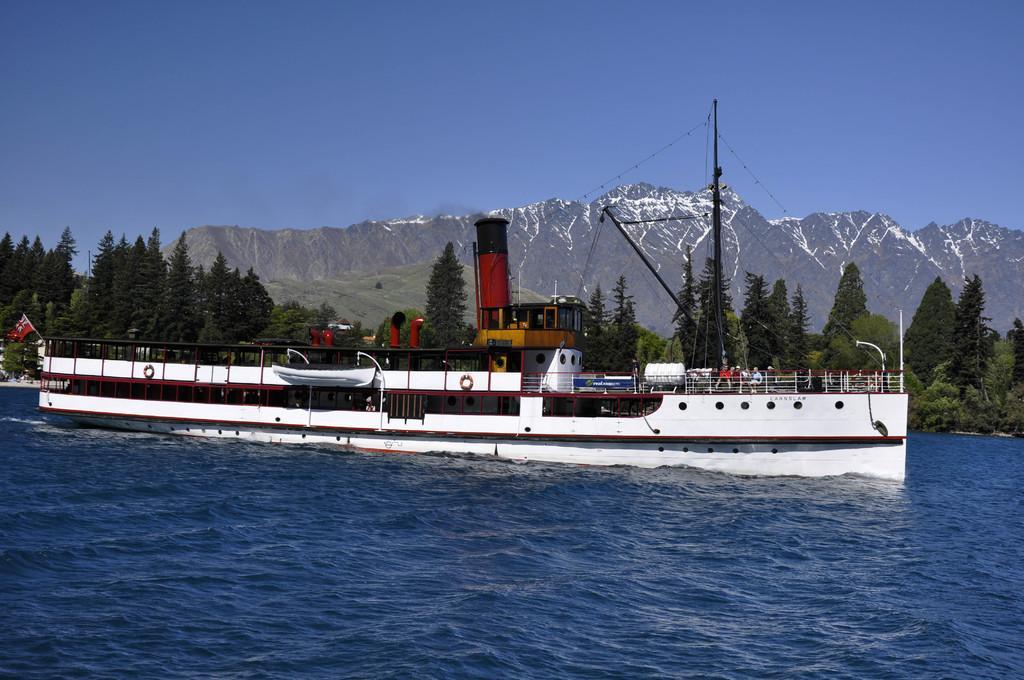Can you describe this image briefly? There is a white ship on the water and people are present in it. There is a pole and wires are present at the right and a red flag at the left. There are trees and mountains at the back. 